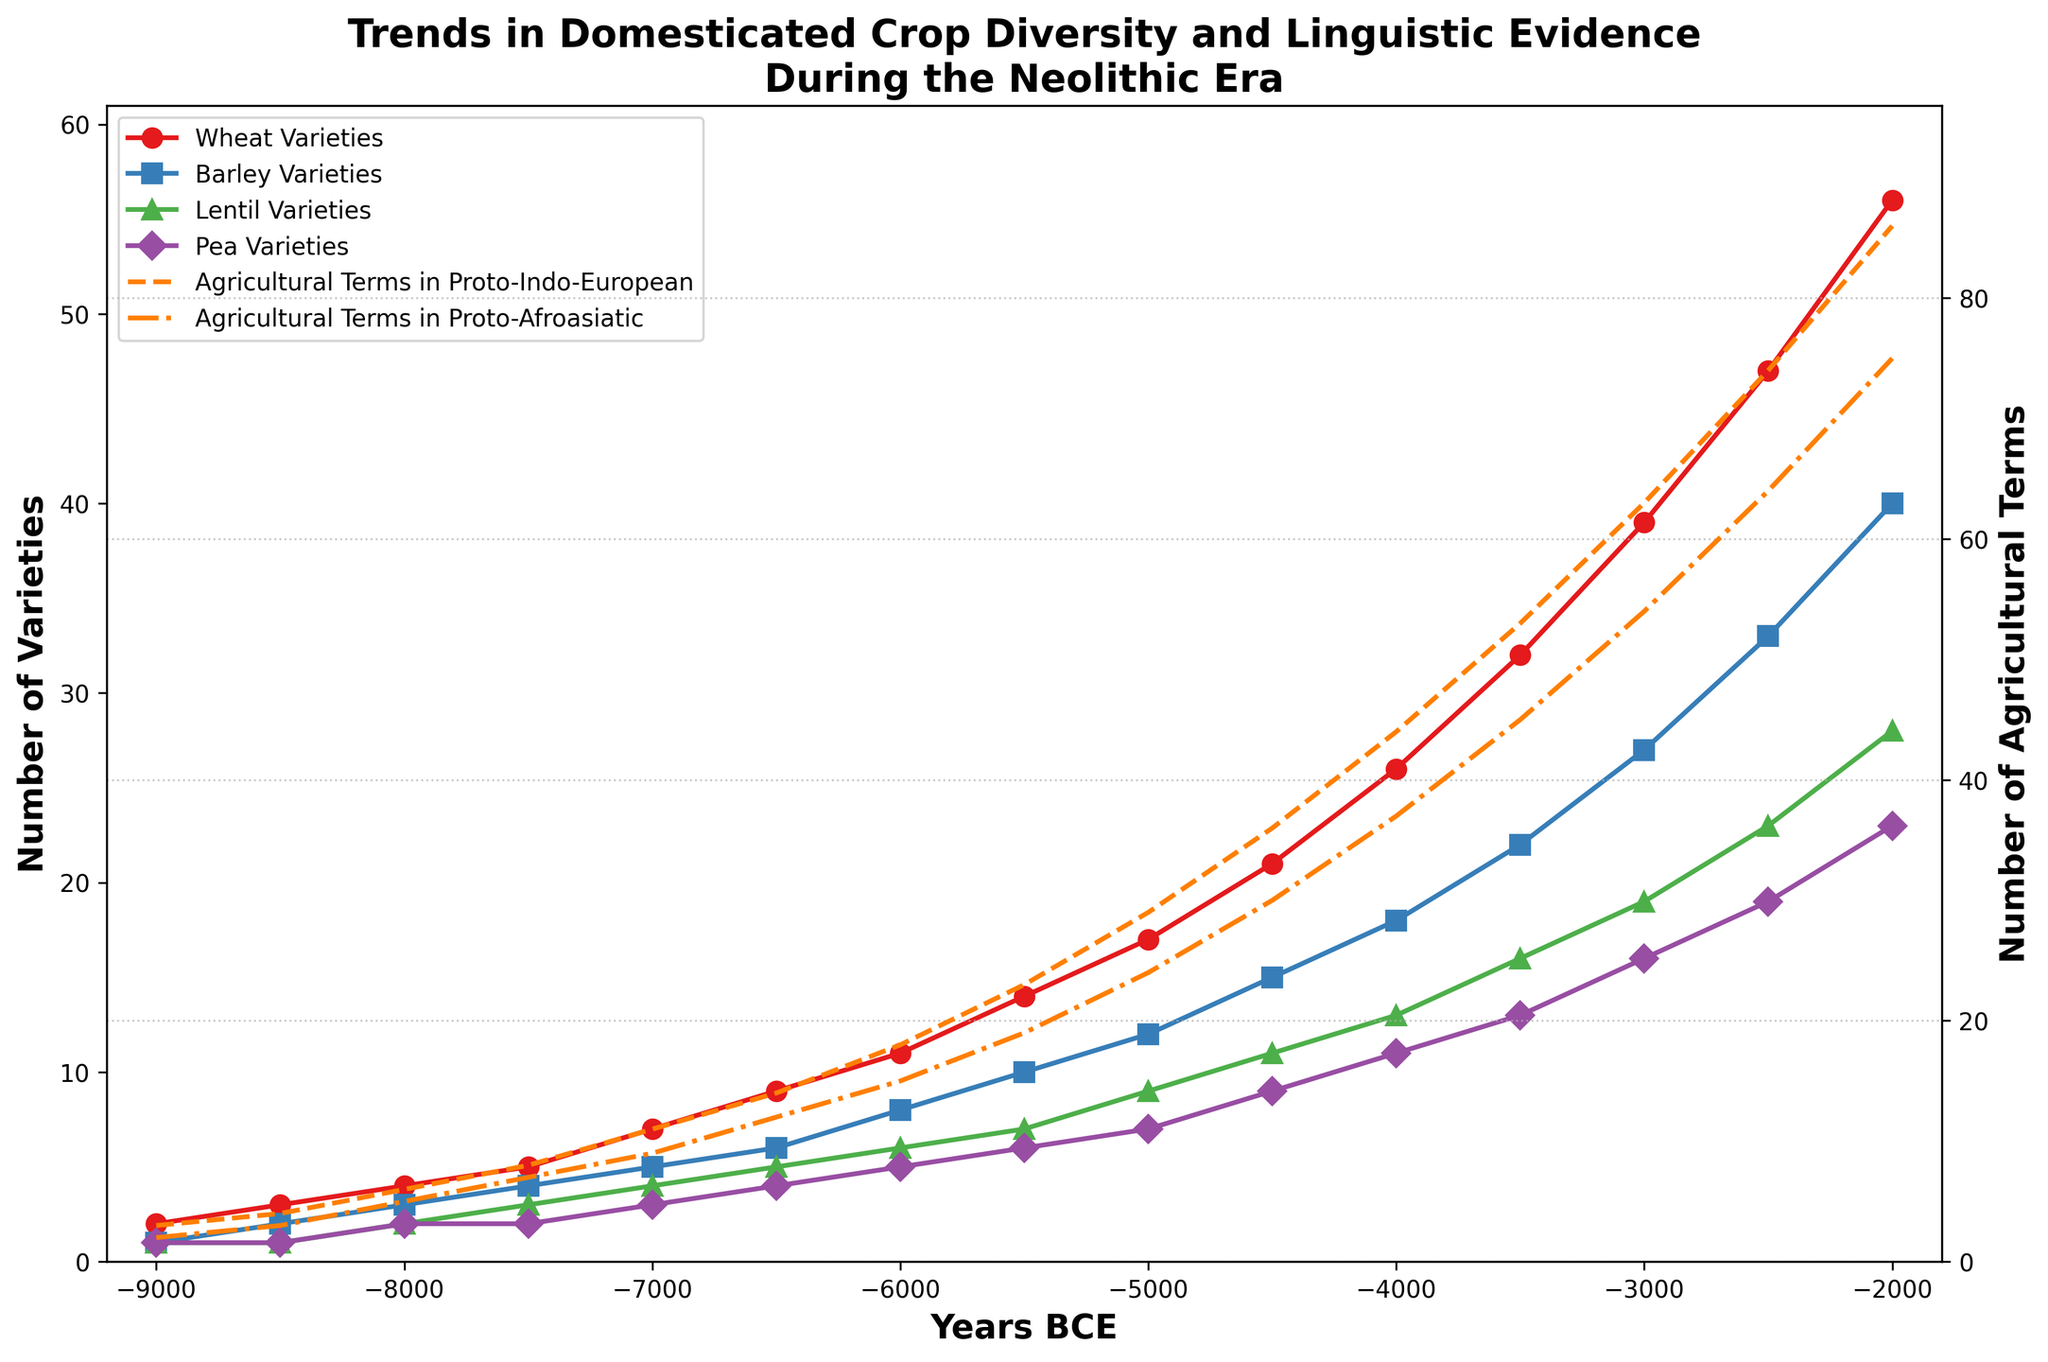What trend do you observe in the variety of wheat throughout the Neolithic era? The graph shows the wheat variety increasing steadily from 2 to 56 between 9000 BCE and 2000 BCE. This observation can be made by tracing the line for wheat varieties on the graph.
Answer: Increasing During which time period did the number of barley varieties exceed the number of lentil varieties and by how much? From 8000 BCE onwards, the number of barley varieties continues to exceed the number of lentil varieties. The difference generally increases, reaching a maximum of 12 in 2000 BCE. This is calculated by subtracting the number of lentil varieties from the number of barley varieties for each corresponding year.
Answer: 8000 BCE onwards, by up to 12 How did the number of agricultural terms in Proto-Afroasiatic languages compare to Proto-Indo-European languages around 4500 BCE? In 4500 BCE, the number of agricultural terms in Proto-Afroasiatic languages was 30, while the number in Proto-Indo-European languages was 36. This comparison is made by checking the corresponding y-values of the lines for the two linguistic groups at 4500 BCE.
Answer: 30 vs. 36 At what year did the number of pea varieties first equal the number of lentil varieties, and how many were there? The number of pea varieties equaled the number of lentil varieties at 7500 BCE, and this number was 3. This can be identified by tracing the points where the lines for pea and lentil varieties cross for the first time.
Answer: 7500 BCE, 3 What was the increase in wheat varieties between 4000 BCE and 2000 BCE? From 4000 BCE to 2000 BCE, the number of wheat varieties increased from 26 to 56. The increase is found by subtracting the wheat varieties at 4000 BCE from those at 2000 BCE: 56 - 26 = 30.
Answer: 30 Do the agricultural terms in Proto-Afroasiatic seem to correlate more closely with any particular crop variety? The number of agricultural terms in Proto-Afroasiatic seems to correlate most closely with wheat varieties. By visually comparing the trend of the line for Proto-Afroasiatic terms with the lines representing crop varieties, the similarity in the trend slope between Proto-Afroasiatic terms and wheat varieties is apparent.
Answer: Wheat varieties Which crop variety had the least growth from 9000 BCE to 2000 BCE, and by how much? The pea variety had the least growth during this period, increasing from 1 to 23. The growth is calculated as the difference between the number of pea varieties at 2000 BCE and 9000 BCE: 23 - 1 = 22.
Answer: Pea, 22 How does the trend in the number of Proto-Indo-European agricultural terms compare to the trend in the number of barley varieties? Both trends show a steady increase, but the number of Proto-Indo-European agricultural terms increases at a faster rate starting from around 6000 BCE. This can be seen by plotting the two lines; the slope of the Proto-Indo-European terms line steepens faster compared to the line for barley varieties.
Answer: Steady increase, Proto-Indo-European terms increase faster 